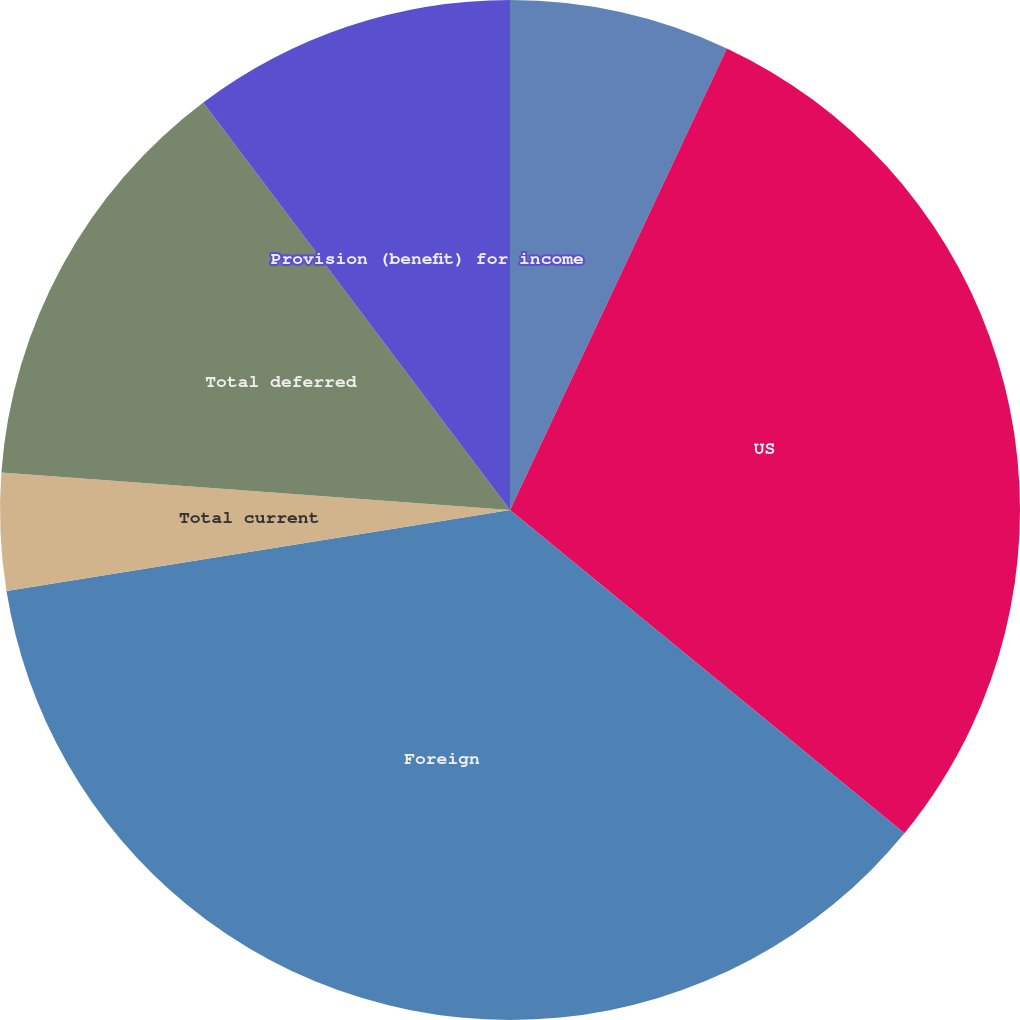<chart> <loc_0><loc_0><loc_500><loc_500><pie_chart><fcel>UK<fcel>US<fcel>Foreign<fcel>Total current<fcel>Total deferred<fcel>Provision (benefit) for income<nl><fcel>6.99%<fcel>28.94%<fcel>36.53%<fcel>3.71%<fcel>13.56%<fcel>10.27%<nl></chart> 